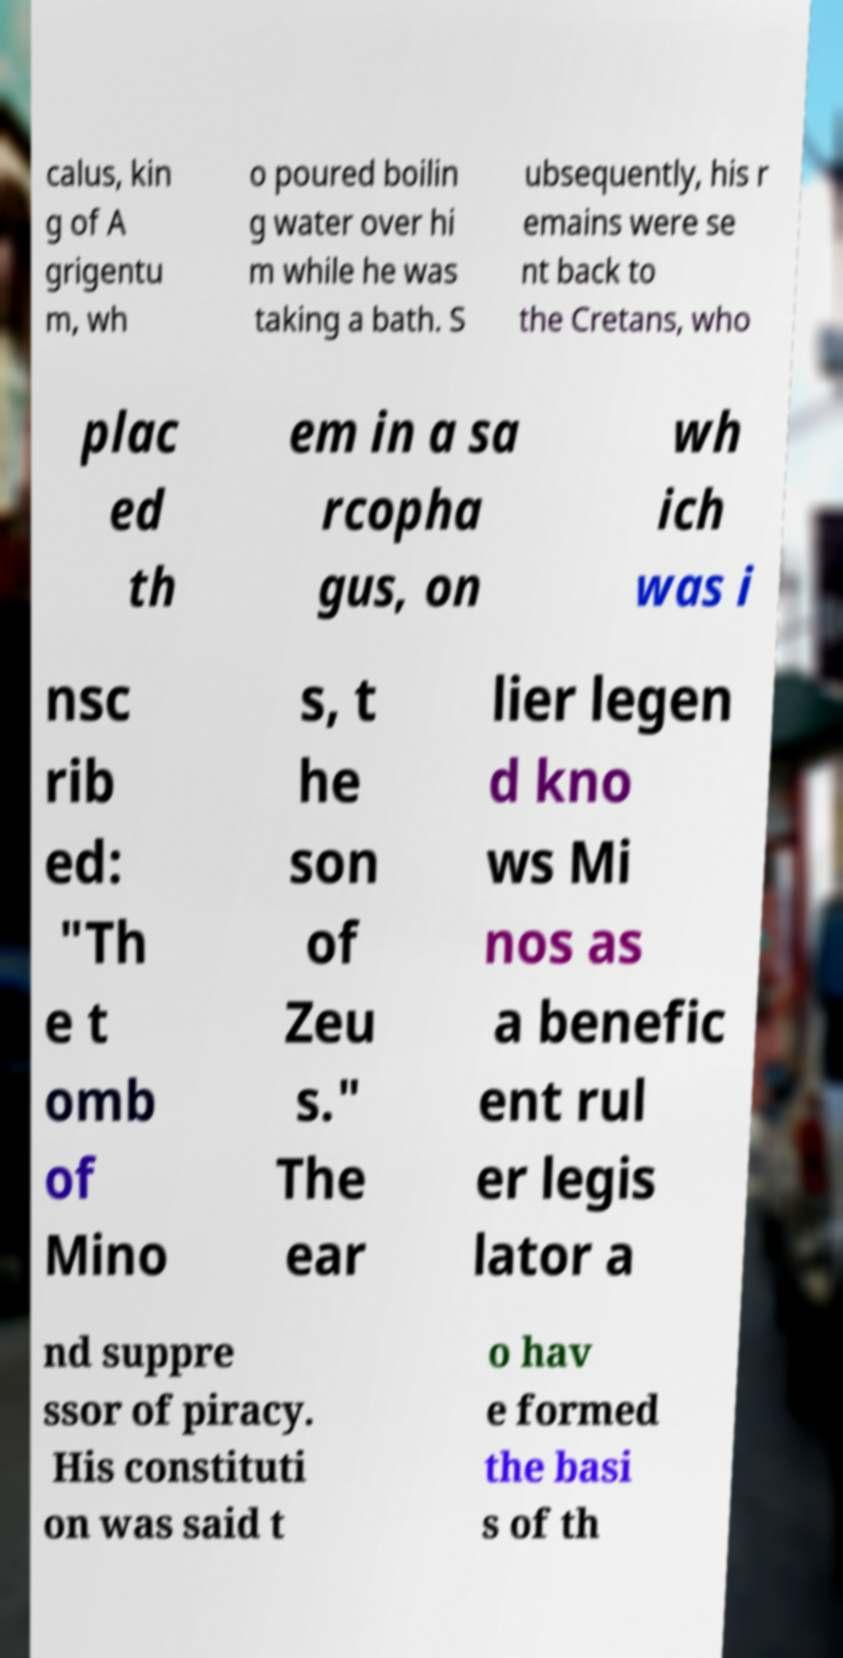Please identify and transcribe the text found in this image. calus, kin g of A grigentu m, wh o poured boilin g water over hi m while he was taking a bath. S ubsequently, his r emains were se nt back to the Cretans, who plac ed th em in a sa rcopha gus, on wh ich was i nsc rib ed: "Th e t omb of Mino s, t he son of Zeu s." The ear lier legen d kno ws Mi nos as a benefic ent rul er legis lator a nd suppre ssor of piracy. His constituti on was said t o hav e formed the basi s of th 